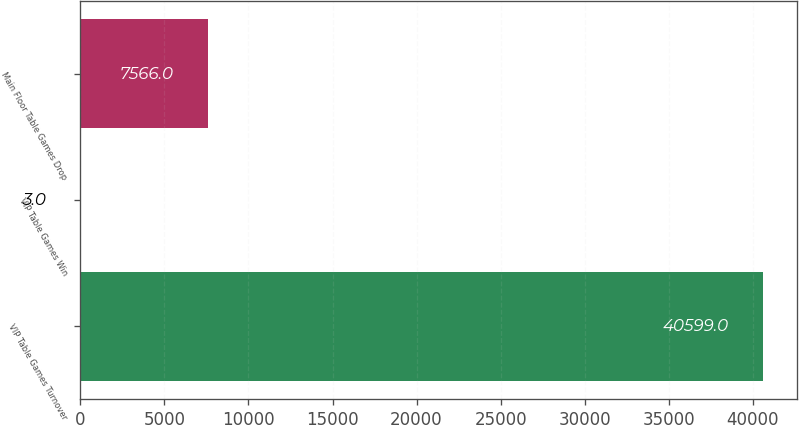Convert chart. <chart><loc_0><loc_0><loc_500><loc_500><bar_chart><fcel>VIP Table Games Turnover<fcel>VIP Table Games Win<fcel>Main Floor Table Games Drop<nl><fcel>40599<fcel>3<fcel>7566<nl></chart> 